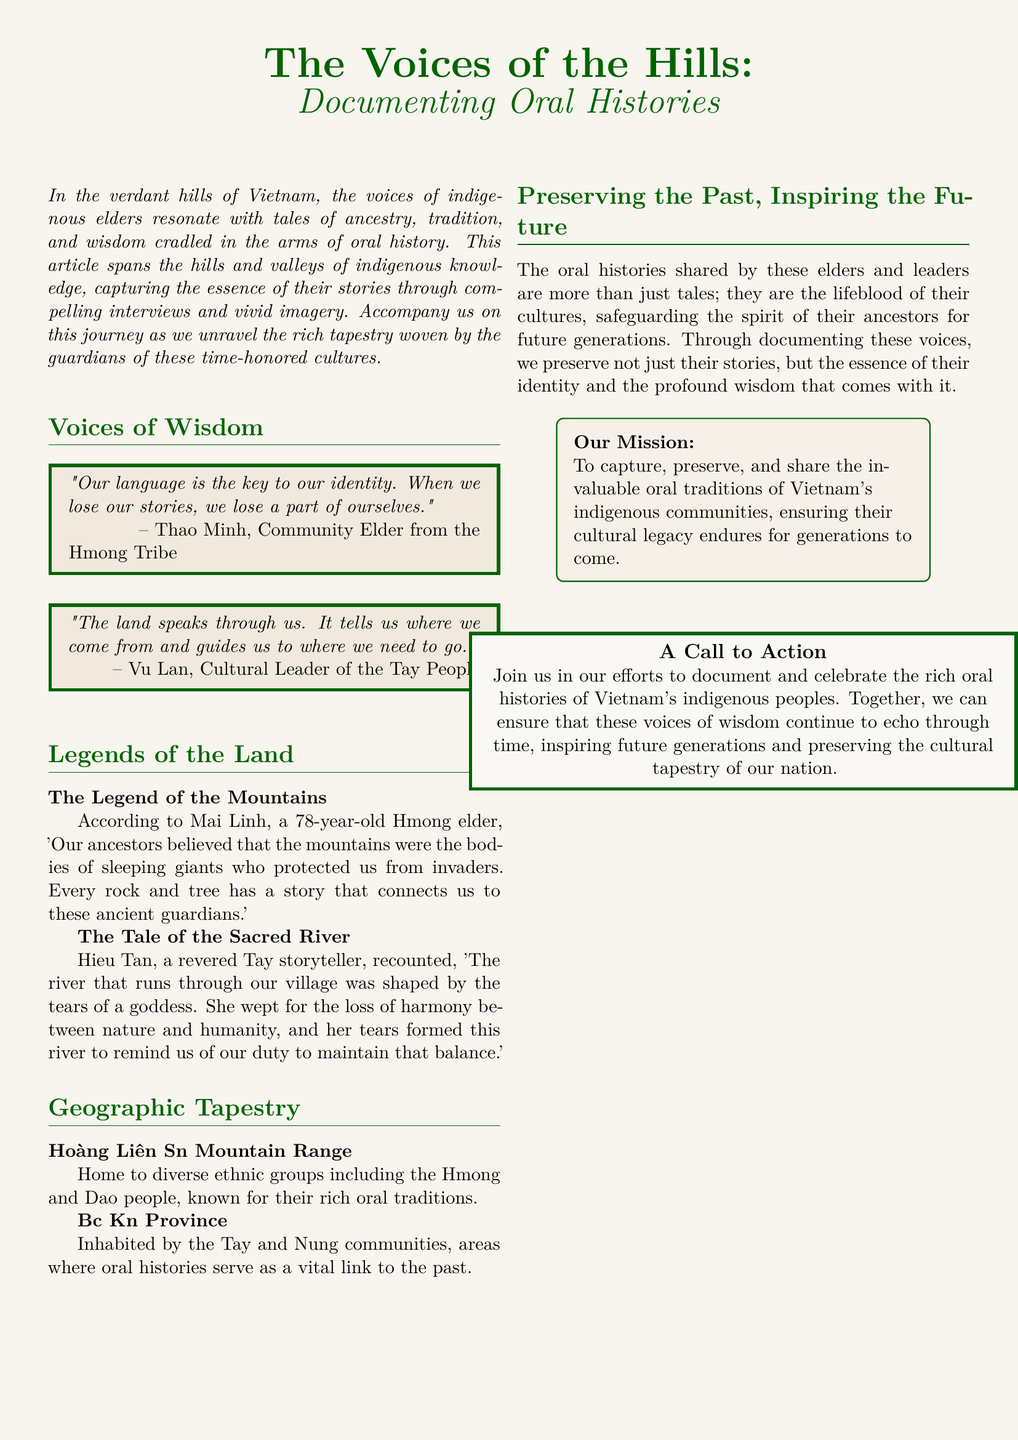What is the title of the article? The title of the article is prominently displayed at the top of the document, highlighting the main theme.
Answer: The Voices of the Hills: Documenting Oral Histories Who is Thao Minh? Thao Minh is identified in the document as a Community Elder from the Hmong Tribe, providing a quote on the importance of language.
Answer: Community Elder from the Hmong Tribe What does Vu Lan say about the land? Vu Lan's quote emphasizes the connection between the land and identity, indicating its importance in guiding individuals.
Answer: The land speaks through us How old is Mai Linh? Mai Linh's age is mentioned in the document to provide context for her perspective on traditional beliefs.
Answer: 78 years old Which geographic area is home to diverse ethnic groups, including the Hmong? The document specifies geographical locations associated with indigenous communities and their oral traditions.
Answer: Hoàng Liên Sơn Mountain Range What is the purpose of the mission stated in the document? The mission details the initiative aimed at preserving specific aspects of cultural heritage in the indigenous communities.
Answer: To capture, preserve, and share the invaluable oral traditions What call to action is mentioned at the end of the article? The call to action encourages readers to participate in the preservation efforts documented in the article.
Answer: Join us in our efforts to document and celebrate How is the layout of the article structured? The structure includes sections with quotes, stories, and a visual representation of geographic locations through maps.
Answer: Multicolumn format with sections and illustrations What theme is emphasized through the interviews and stories provided? The interviews and stories converge around the core aspect of cultural heritage and the significance of oral history.
Answer: Cultural preservation 